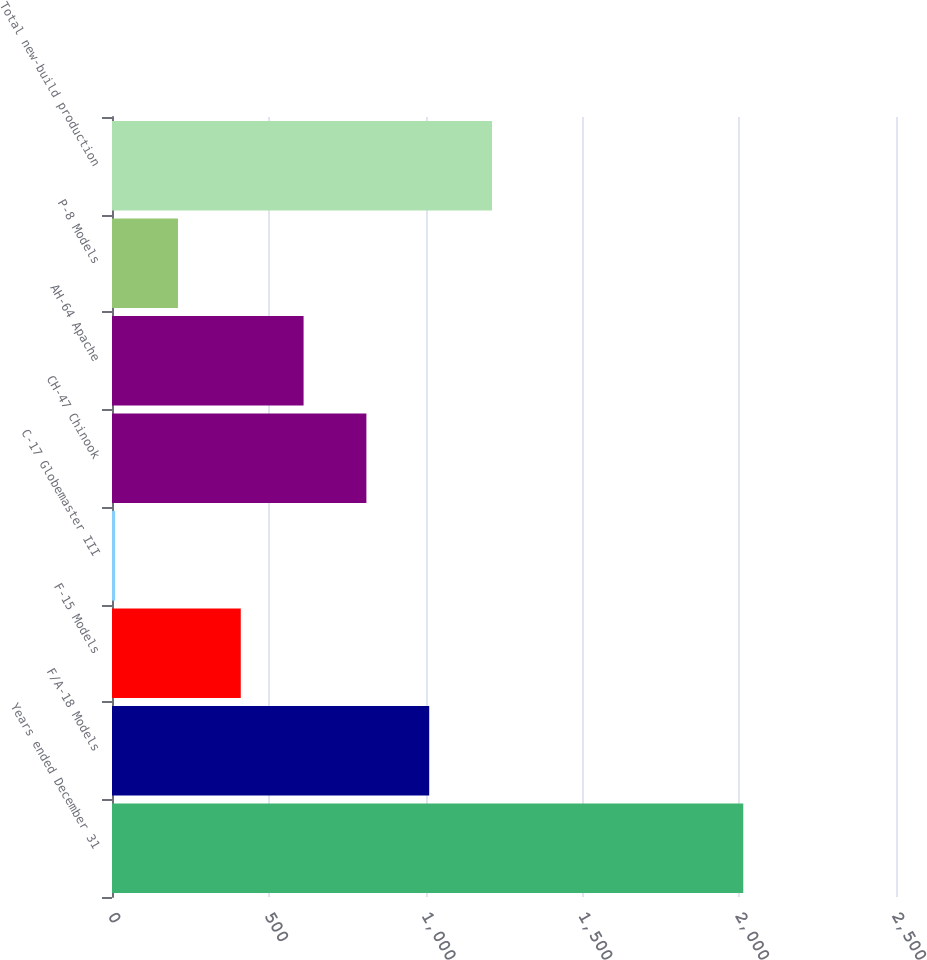<chart> <loc_0><loc_0><loc_500><loc_500><bar_chart><fcel>Years ended December 31<fcel>F/A-18 Models<fcel>F-15 Models<fcel>C-17 Globemaster III<fcel>CH-47 Chinook<fcel>AH-64 Apache<fcel>P-8 Models<fcel>Total new-build production<nl><fcel>2013<fcel>1011.5<fcel>410.6<fcel>10<fcel>811.2<fcel>610.9<fcel>210.3<fcel>1211.8<nl></chart> 